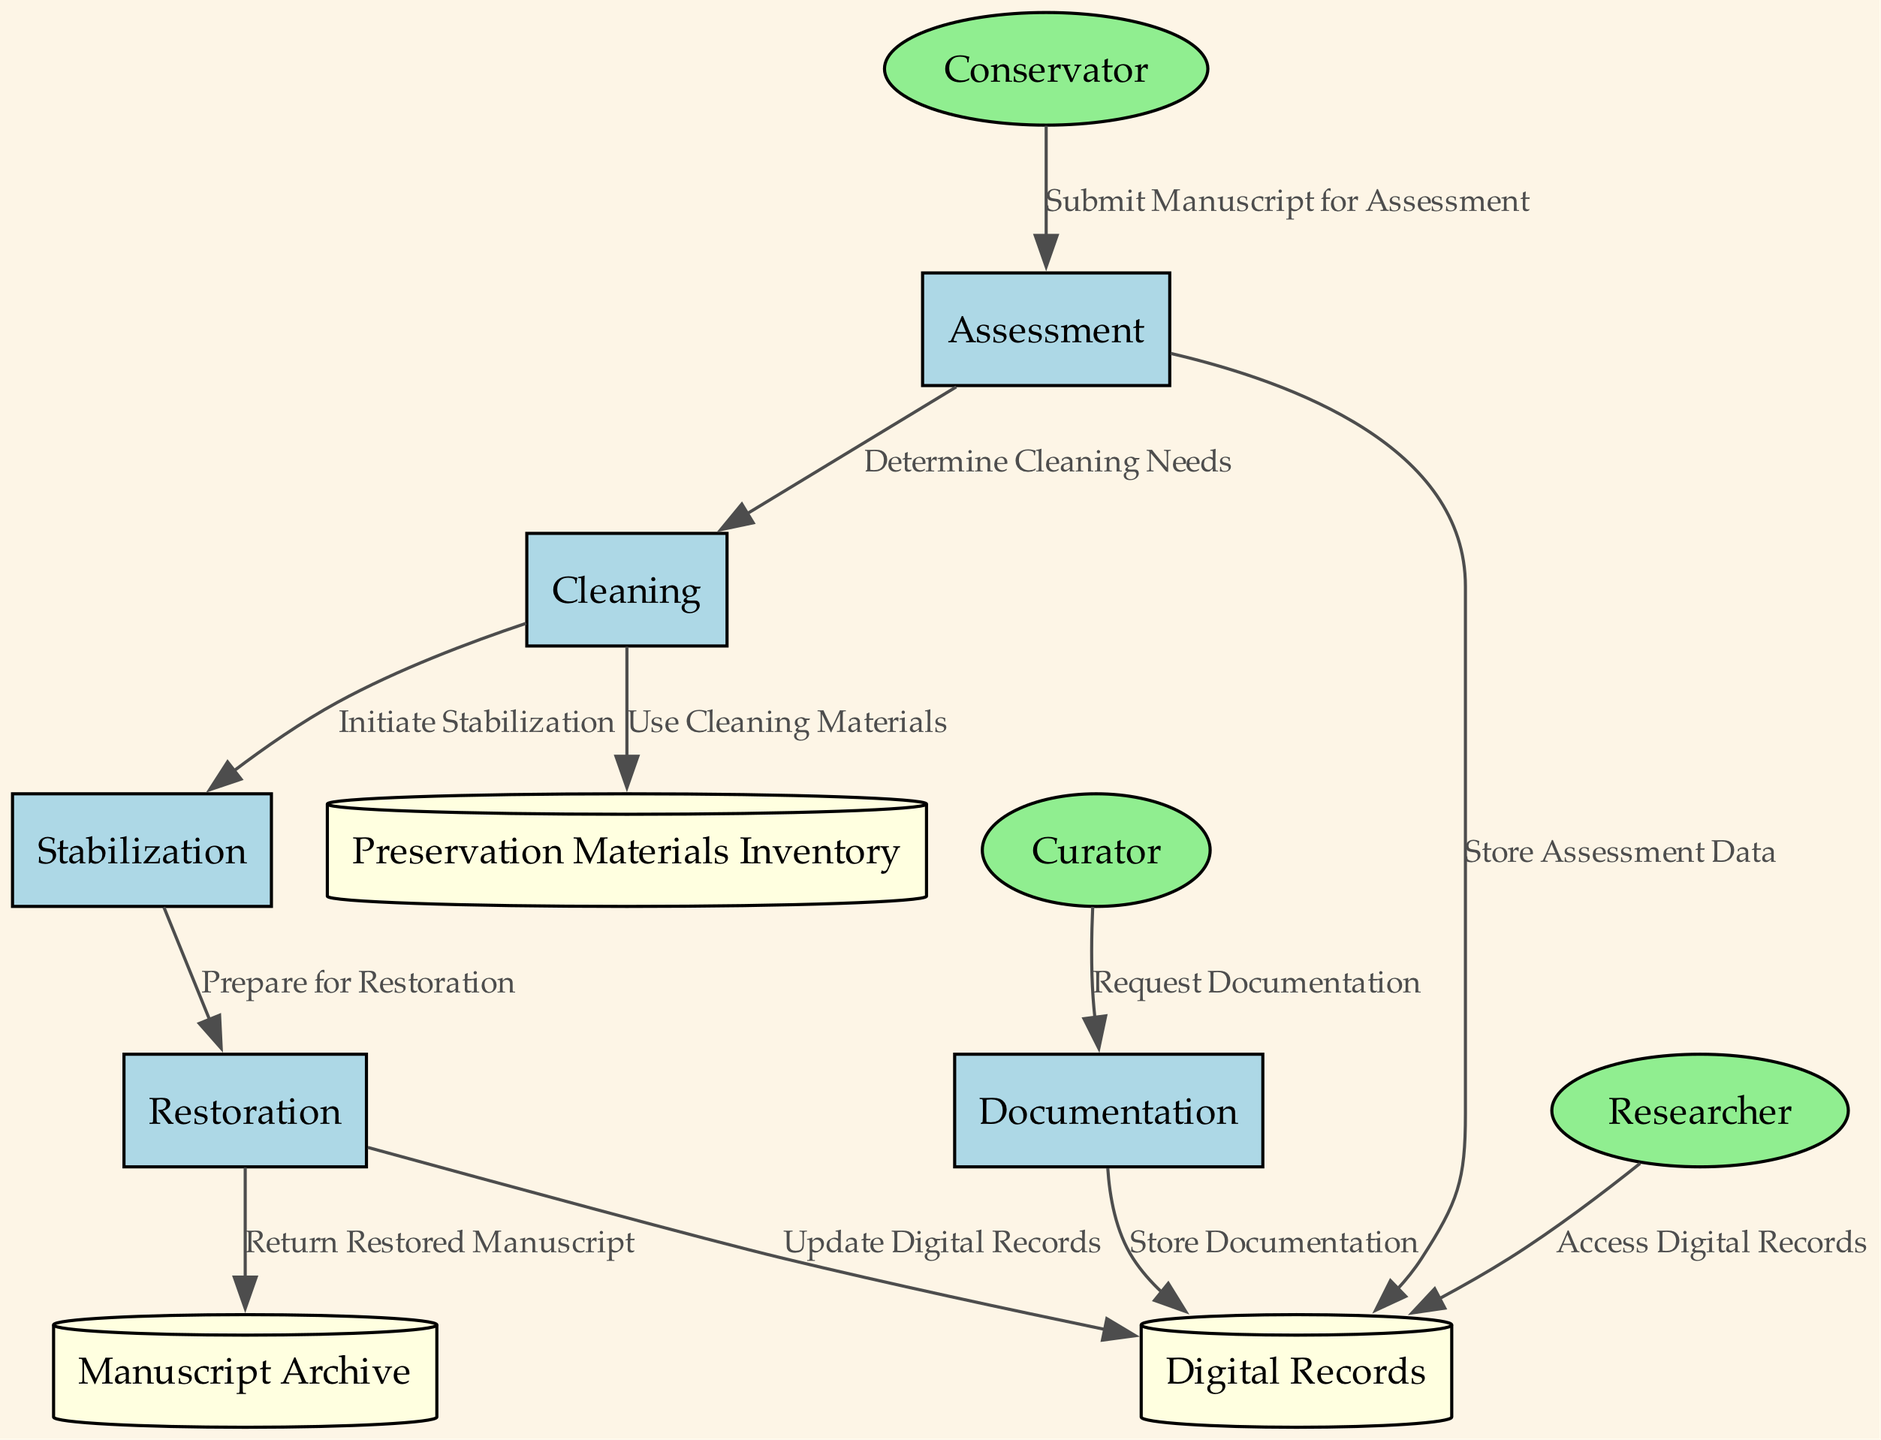What is the first process in the preservation workflow? The workflow starts with the 'Assessment' process, which is identified as the first process in the diagram.
Answer: Assessment How many data stores are present in the diagram? There are three data stores listed in the diagram: 'Manuscript Archive', 'Digital Records', and 'Preservation Materials Inventory'.
Answer: 3 Which entity initiates the 'Cleaning' process? The 'Cleaning' process is initiated after the 'Assessment' process is complete, led by the 'Conservator' entity who determines cleaning needs based on the assessment.
Answer: Conservator What type of node represents 'Preservation Materials Inventory'? The 'Preservation Materials Inventory' is represented as a cylinder, which is the standard shape used for data stores in data flow diagrams.
Answer: Cylinder What flow occurs after the 'Stabilization' process? After the 'Stabilization' process, the next flow is 'Prepare for Restoration', which indicates that stabilization is the precursor to restoration.
Answer: Prepare for Restoration How many edges connect external entities to processes? There are four edges that connect external entities ('Conservator', 'Curator', 'Researcher') to various processes in the diagram, indicating interactions with the processes.
Answer: 4 What happens to the manuscript after the 'Restoration' process? Once the 'Restoration' process is completed, the manuscript is returned to the 'Manuscript Archive', indicating that the restored manuscript is stored back in the original location.
Answer: Return Restored Manuscript Which process receives a request from the Curator? The 'Documentation' process receives a request from the Curator, who seeks detailed documentation regarding the manuscript's history and its restoration process.
Answer: Documentation What is the purpose of the 'Digital Records' store? The 'Digital Records' store is used to hold high-resolution images and descriptive metadata about the manuscripts, serving as a digital repository for the preservation efforts.
Answer: Digital repository 